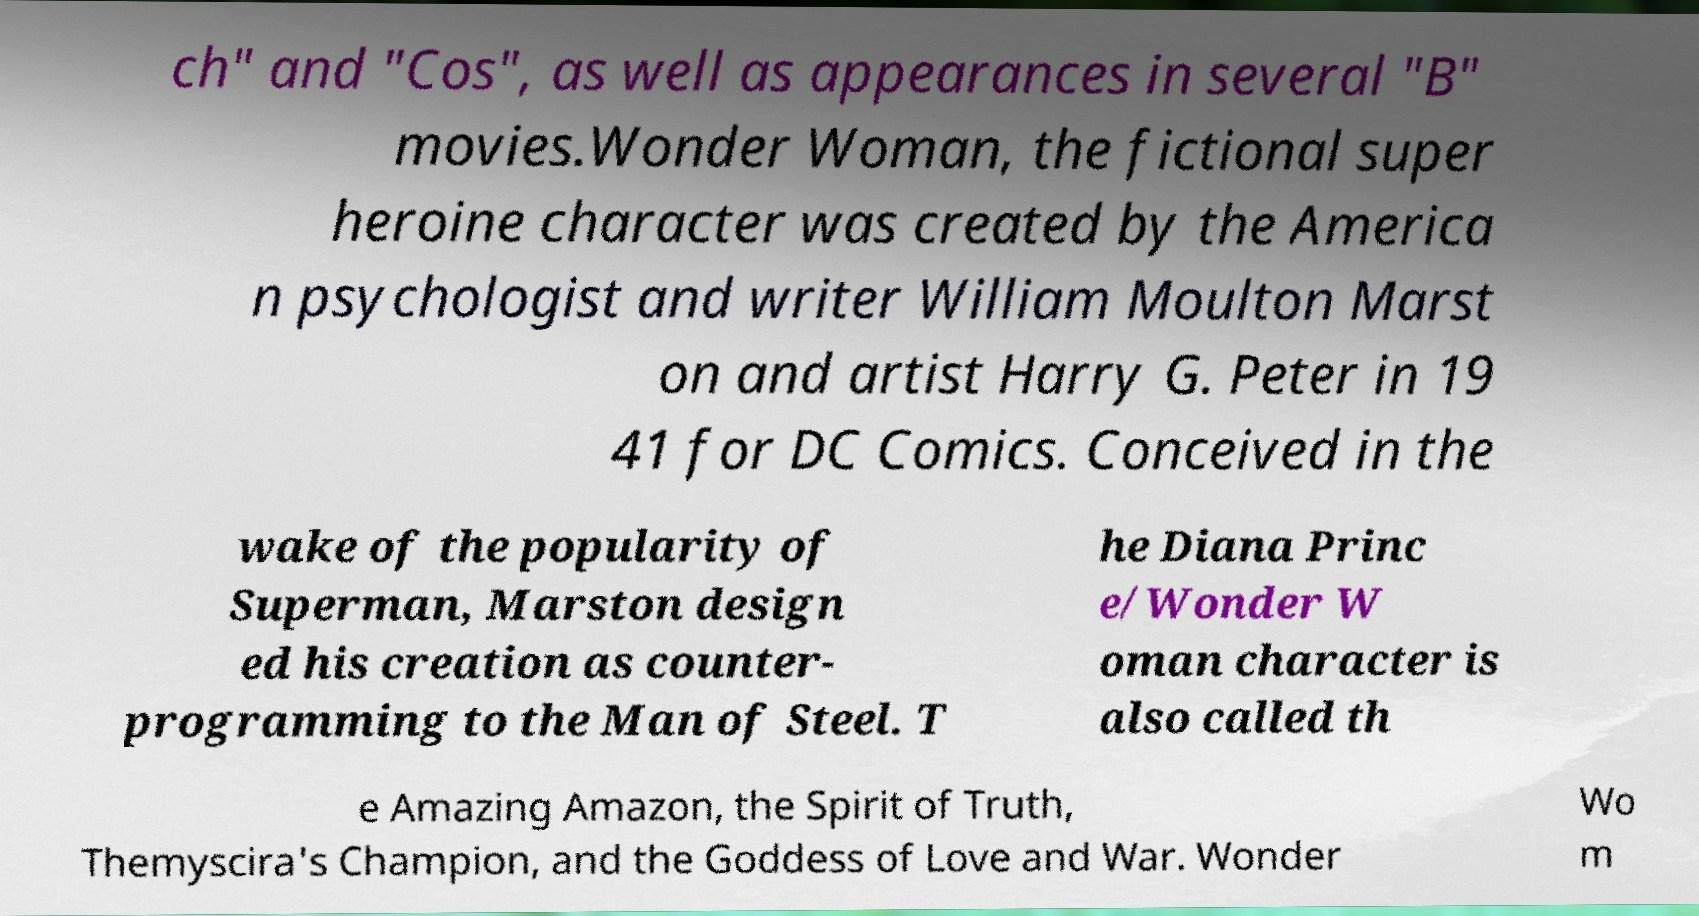Please read and relay the text visible in this image. What does it say? ch" and "Cos", as well as appearances in several "B" movies.Wonder Woman, the fictional super heroine character was created by the America n psychologist and writer William Moulton Marst on and artist Harry G. Peter in 19 41 for DC Comics. Conceived in the wake of the popularity of Superman, Marston design ed his creation as counter- programming to the Man of Steel. T he Diana Princ e/Wonder W oman character is also called th e Amazing Amazon, the Spirit of Truth, Themyscira's Champion, and the Goddess of Love and War. Wonder Wo m 